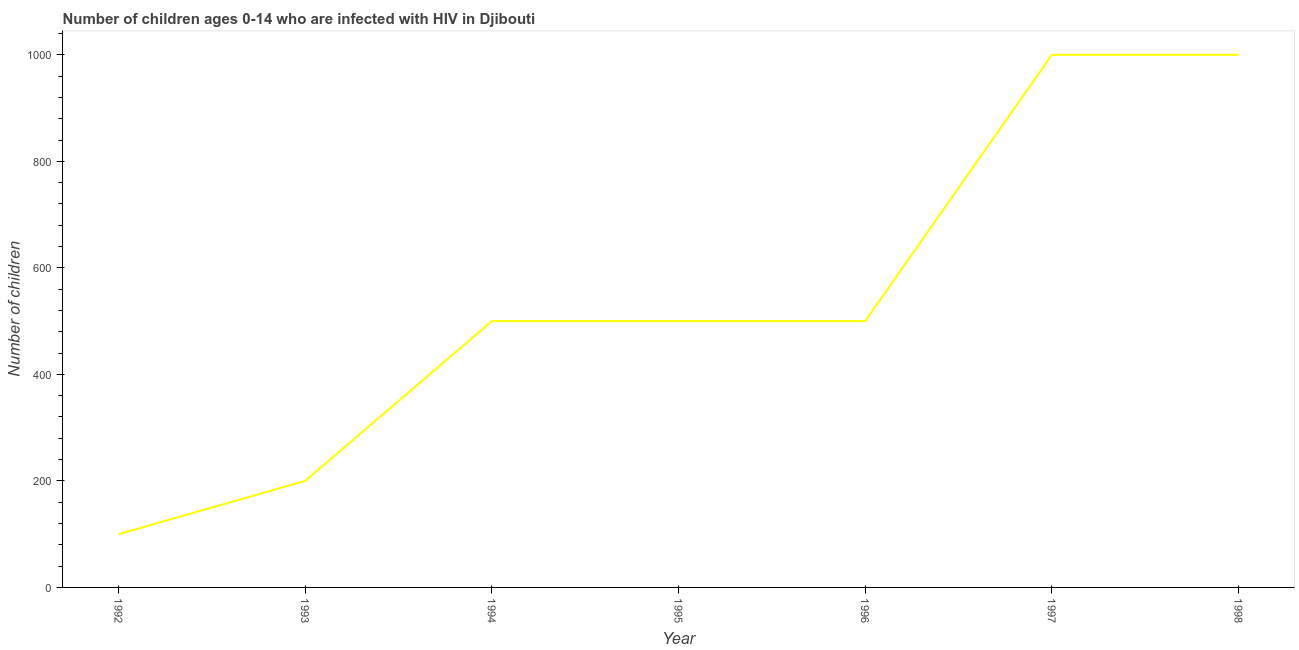What is the number of children living with hiv in 1993?
Provide a short and direct response. 200. Across all years, what is the maximum number of children living with hiv?
Keep it short and to the point. 1000. Across all years, what is the minimum number of children living with hiv?
Your response must be concise. 100. In which year was the number of children living with hiv maximum?
Provide a short and direct response. 1997. What is the sum of the number of children living with hiv?
Keep it short and to the point. 3800. What is the difference between the number of children living with hiv in 1992 and 1995?
Offer a terse response. -400. What is the average number of children living with hiv per year?
Your response must be concise. 542.86. What is the median number of children living with hiv?
Your response must be concise. 500. Do a majority of the years between 1994 and 1992 (inclusive) have number of children living with hiv greater than 520 ?
Give a very brief answer. No. What is the ratio of the number of children living with hiv in 1992 to that in 1994?
Your response must be concise. 0.2. Is the difference between the number of children living with hiv in 1992 and 1994 greater than the difference between any two years?
Provide a short and direct response. No. What is the difference between the highest and the second highest number of children living with hiv?
Give a very brief answer. 0. Is the sum of the number of children living with hiv in 1992 and 1995 greater than the maximum number of children living with hiv across all years?
Your answer should be compact. No. What is the difference between the highest and the lowest number of children living with hiv?
Keep it short and to the point. 900. In how many years, is the number of children living with hiv greater than the average number of children living with hiv taken over all years?
Your answer should be very brief. 2. Does the number of children living with hiv monotonically increase over the years?
Your answer should be very brief. No. How many lines are there?
Keep it short and to the point. 1. What is the difference between two consecutive major ticks on the Y-axis?
Your response must be concise. 200. What is the title of the graph?
Give a very brief answer. Number of children ages 0-14 who are infected with HIV in Djibouti. What is the label or title of the Y-axis?
Offer a very short reply. Number of children. What is the Number of children of 1993?
Keep it short and to the point. 200. What is the Number of children in 1994?
Make the answer very short. 500. What is the Number of children of 1995?
Provide a short and direct response. 500. What is the Number of children of 1997?
Your answer should be compact. 1000. What is the difference between the Number of children in 1992 and 1993?
Give a very brief answer. -100. What is the difference between the Number of children in 1992 and 1994?
Give a very brief answer. -400. What is the difference between the Number of children in 1992 and 1995?
Offer a terse response. -400. What is the difference between the Number of children in 1992 and 1996?
Offer a very short reply. -400. What is the difference between the Number of children in 1992 and 1997?
Ensure brevity in your answer.  -900. What is the difference between the Number of children in 1992 and 1998?
Your answer should be very brief. -900. What is the difference between the Number of children in 1993 and 1994?
Ensure brevity in your answer.  -300. What is the difference between the Number of children in 1993 and 1995?
Your answer should be compact. -300. What is the difference between the Number of children in 1993 and 1996?
Your response must be concise. -300. What is the difference between the Number of children in 1993 and 1997?
Provide a succinct answer. -800. What is the difference between the Number of children in 1993 and 1998?
Your response must be concise. -800. What is the difference between the Number of children in 1994 and 1996?
Offer a very short reply. 0. What is the difference between the Number of children in 1994 and 1997?
Keep it short and to the point. -500. What is the difference between the Number of children in 1994 and 1998?
Make the answer very short. -500. What is the difference between the Number of children in 1995 and 1997?
Offer a very short reply. -500. What is the difference between the Number of children in 1995 and 1998?
Offer a terse response. -500. What is the difference between the Number of children in 1996 and 1997?
Offer a very short reply. -500. What is the difference between the Number of children in 1996 and 1998?
Provide a short and direct response. -500. What is the ratio of the Number of children in 1992 to that in 1994?
Keep it short and to the point. 0.2. What is the ratio of the Number of children in 1992 to that in 1995?
Ensure brevity in your answer.  0.2. What is the ratio of the Number of children in 1993 to that in 1995?
Keep it short and to the point. 0.4. What is the ratio of the Number of children in 1993 to that in 1998?
Make the answer very short. 0.2. What is the ratio of the Number of children in 1994 to that in 1995?
Your answer should be very brief. 1. What is the ratio of the Number of children in 1994 to that in 1997?
Ensure brevity in your answer.  0.5. What is the ratio of the Number of children in 1994 to that in 1998?
Ensure brevity in your answer.  0.5. What is the ratio of the Number of children in 1995 to that in 1996?
Your answer should be compact. 1. What is the ratio of the Number of children in 1995 to that in 1997?
Ensure brevity in your answer.  0.5. What is the ratio of the Number of children in 1996 to that in 1997?
Offer a terse response. 0.5. What is the ratio of the Number of children in 1996 to that in 1998?
Your response must be concise. 0.5. 